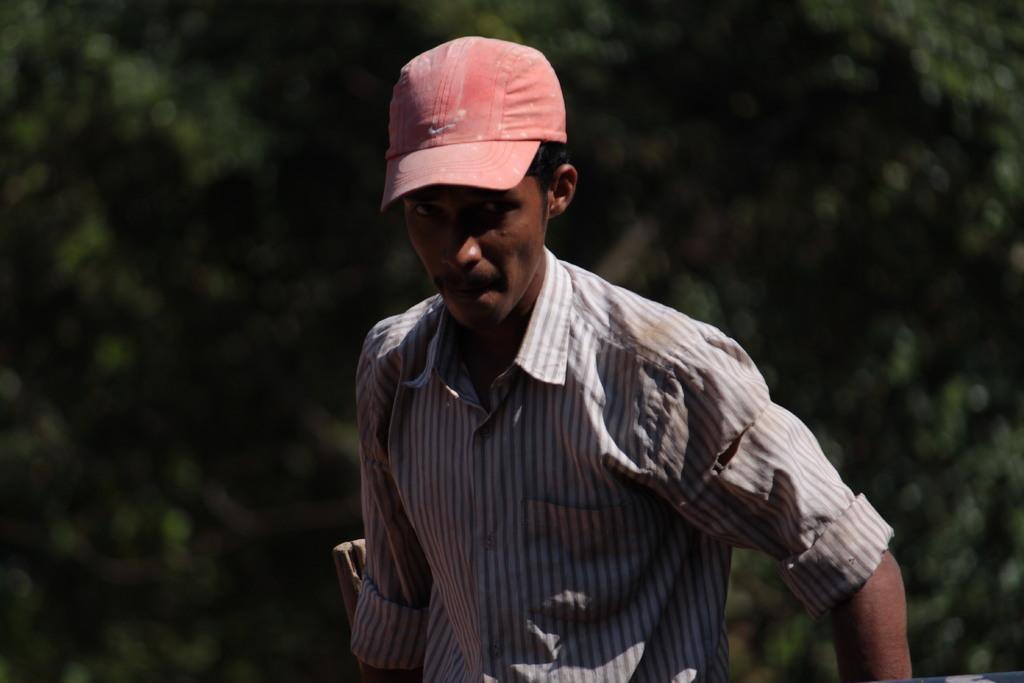Could you give a brief overview of what you see in this image? Background portion of the picture is blurred. In this picture we can see a man wearing a shirt and cap. 